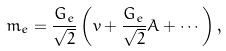<formula> <loc_0><loc_0><loc_500><loc_500>m _ { e } = \frac { G _ { e } } { \sqrt { 2 } } \left ( v + \frac { G _ { e } } { \sqrt { 2 } } A + \cdots \right ) ,</formula> 